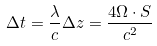Convert formula to latex. <formula><loc_0><loc_0><loc_500><loc_500>\Delta t = \frac { \lambda } { c } \Delta z = \frac { 4 { \Omega \cdot S } } { c ^ { 2 } }</formula> 